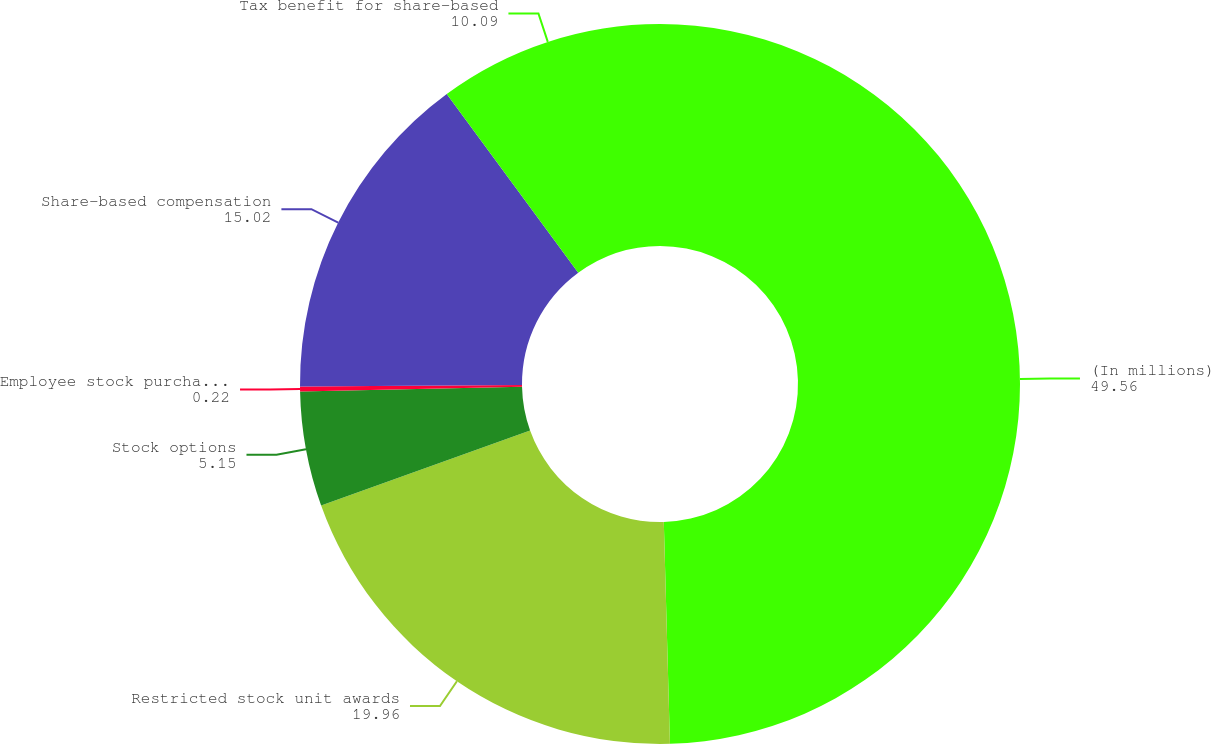Convert chart. <chart><loc_0><loc_0><loc_500><loc_500><pie_chart><fcel>(In millions)<fcel>Restricted stock unit awards<fcel>Stock options<fcel>Employee stock purchase plan<fcel>Share-based compensation<fcel>Tax benefit for share-based<nl><fcel>49.56%<fcel>19.96%<fcel>5.15%<fcel>0.22%<fcel>15.02%<fcel>10.09%<nl></chart> 